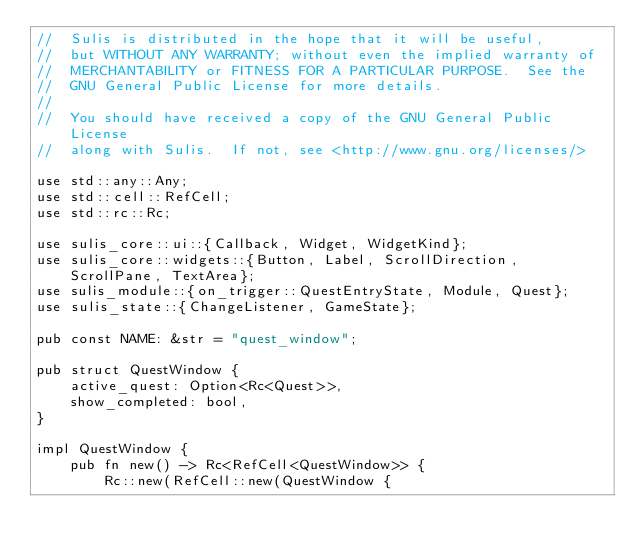<code> <loc_0><loc_0><loc_500><loc_500><_Rust_>//  Sulis is distributed in the hope that it will be useful,
//  but WITHOUT ANY WARRANTY; without even the implied warranty of
//  MERCHANTABILITY or FITNESS FOR A PARTICULAR PURPOSE.  See the
//  GNU General Public License for more details.
//
//  You should have received a copy of the GNU General Public License
//  along with Sulis.  If not, see <http://www.gnu.org/licenses/>

use std::any::Any;
use std::cell::RefCell;
use std::rc::Rc;

use sulis_core::ui::{Callback, Widget, WidgetKind};
use sulis_core::widgets::{Button, Label, ScrollDirection, ScrollPane, TextArea};
use sulis_module::{on_trigger::QuestEntryState, Module, Quest};
use sulis_state::{ChangeListener, GameState};

pub const NAME: &str = "quest_window";

pub struct QuestWindow {
    active_quest: Option<Rc<Quest>>,
    show_completed: bool,
}

impl QuestWindow {
    pub fn new() -> Rc<RefCell<QuestWindow>> {
        Rc::new(RefCell::new(QuestWindow {</code> 